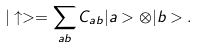<formula> <loc_0><loc_0><loc_500><loc_500>| \uparrow > = \sum _ { a b } C _ { a b } | a > \otimes | b > .</formula> 